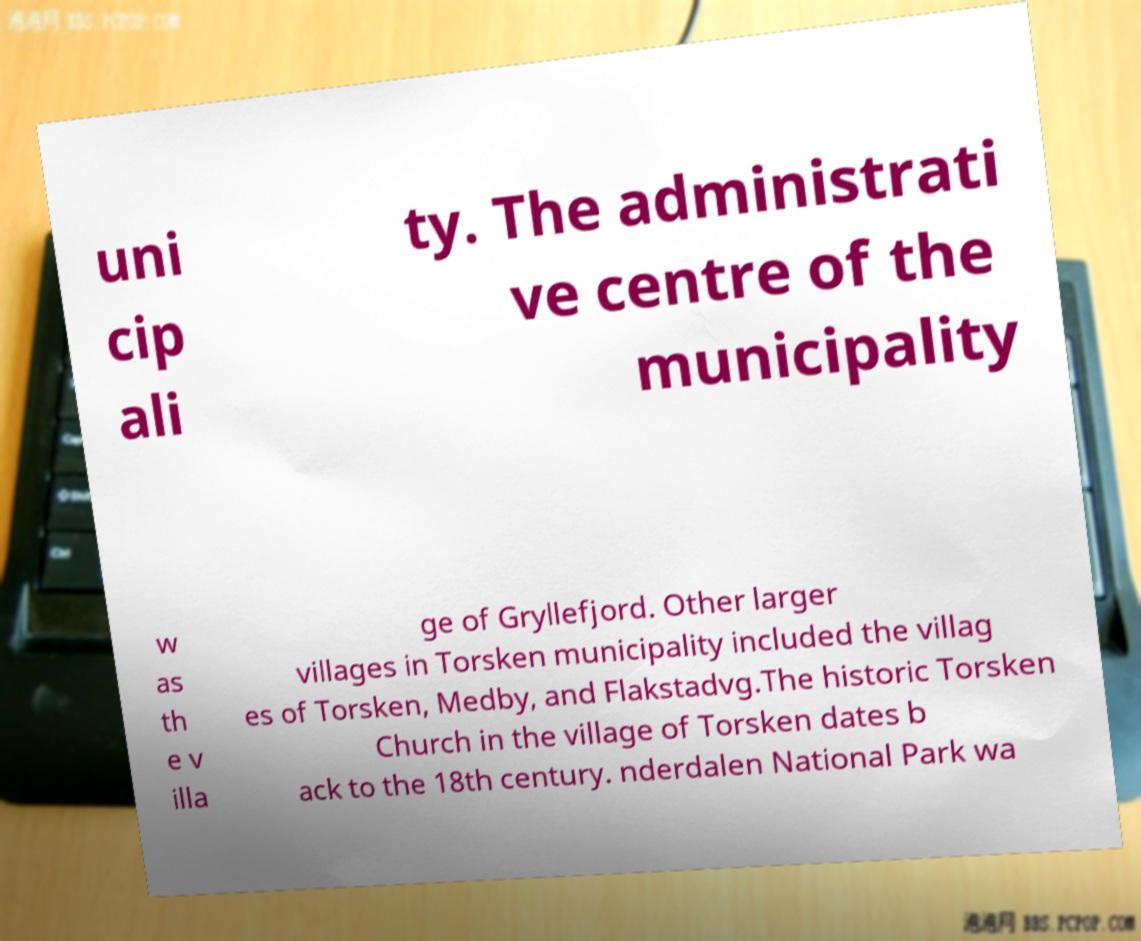Can you read and provide the text displayed in the image?This photo seems to have some interesting text. Can you extract and type it out for me? uni cip ali ty. The administrati ve centre of the municipality w as th e v illa ge of Gryllefjord. Other larger villages in Torsken municipality included the villag es of Torsken, Medby, and Flakstadvg.The historic Torsken Church in the village of Torsken dates b ack to the 18th century. nderdalen National Park wa 